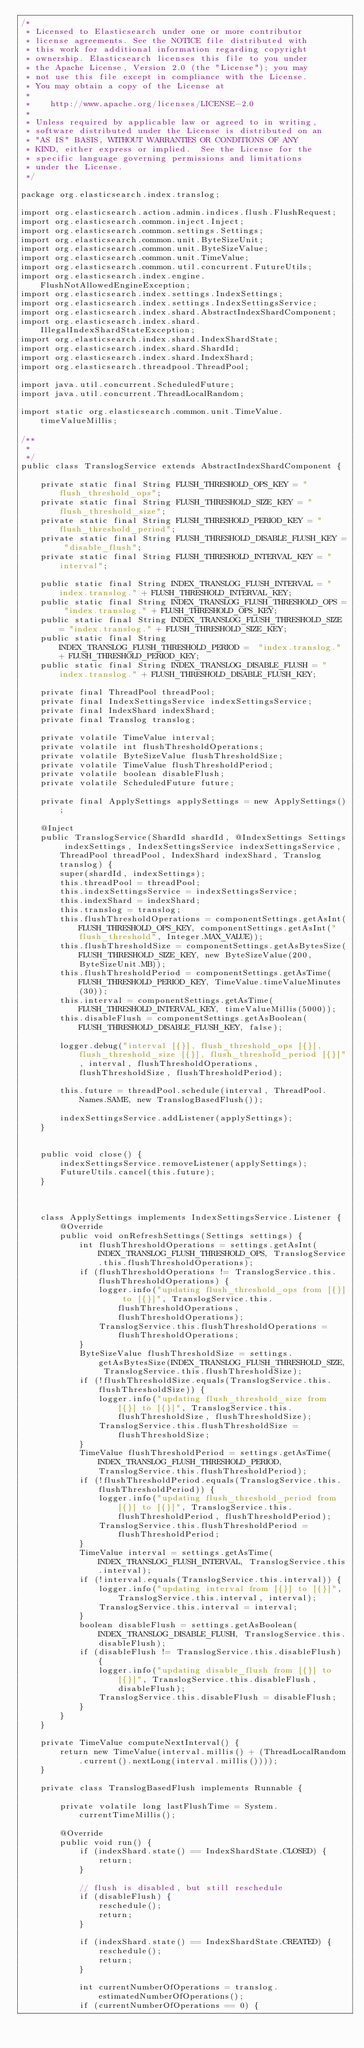Convert code to text. <code><loc_0><loc_0><loc_500><loc_500><_Java_>/*
 * Licensed to Elasticsearch under one or more contributor
 * license agreements. See the NOTICE file distributed with
 * this work for additional information regarding copyright
 * ownership. Elasticsearch licenses this file to you under
 * the Apache License, Version 2.0 (the "License"); you may
 * not use this file except in compliance with the License.
 * You may obtain a copy of the License at
 *
 *    http://www.apache.org/licenses/LICENSE-2.0
 *
 * Unless required by applicable law or agreed to in writing,
 * software distributed under the License is distributed on an
 * "AS IS" BASIS, WITHOUT WARRANTIES OR CONDITIONS OF ANY
 * KIND, either express or implied.  See the License for the
 * specific language governing permissions and limitations
 * under the License.
 */

package org.elasticsearch.index.translog;

import org.elasticsearch.action.admin.indices.flush.FlushRequest;
import org.elasticsearch.common.inject.Inject;
import org.elasticsearch.common.settings.Settings;
import org.elasticsearch.common.unit.ByteSizeUnit;
import org.elasticsearch.common.unit.ByteSizeValue;
import org.elasticsearch.common.unit.TimeValue;
import org.elasticsearch.common.util.concurrent.FutureUtils;
import org.elasticsearch.index.engine.FlushNotAllowedEngineException;
import org.elasticsearch.index.settings.IndexSettings;
import org.elasticsearch.index.settings.IndexSettingsService;
import org.elasticsearch.index.shard.AbstractIndexShardComponent;
import org.elasticsearch.index.shard.IllegalIndexShardStateException;
import org.elasticsearch.index.shard.IndexShardState;
import org.elasticsearch.index.shard.ShardId;
import org.elasticsearch.index.shard.IndexShard;
import org.elasticsearch.threadpool.ThreadPool;

import java.util.concurrent.ScheduledFuture;
import java.util.concurrent.ThreadLocalRandom;

import static org.elasticsearch.common.unit.TimeValue.timeValueMillis;

/**
 *
 */
public class TranslogService extends AbstractIndexShardComponent {

    private static final String FLUSH_THRESHOLD_OPS_KEY = "flush_threshold_ops";
    private static final String FLUSH_THRESHOLD_SIZE_KEY = "flush_threshold_size";
    private static final String FLUSH_THRESHOLD_PERIOD_KEY = "flush_threshold_period";
    private static final String FLUSH_THRESHOLD_DISABLE_FLUSH_KEY = "disable_flush";
    private static final String FLUSH_THRESHOLD_INTERVAL_KEY = "interval";

    public static final String INDEX_TRANSLOG_FLUSH_INTERVAL = "index.translog." + FLUSH_THRESHOLD_INTERVAL_KEY;
    public static final String INDEX_TRANSLOG_FLUSH_THRESHOLD_OPS = "index.translog." + FLUSH_THRESHOLD_OPS_KEY;
    public static final String INDEX_TRANSLOG_FLUSH_THRESHOLD_SIZE = "index.translog." + FLUSH_THRESHOLD_SIZE_KEY;
    public static final String INDEX_TRANSLOG_FLUSH_THRESHOLD_PERIOD =  "index.translog." + FLUSH_THRESHOLD_PERIOD_KEY;
    public static final String INDEX_TRANSLOG_DISABLE_FLUSH = "index.translog." + FLUSH_THRESHOLD_DISABLE_FLUSH_KEY;

    private final ThreadPool threadPool;
    private final IndexSettingsService indexSettingsService;
    private final IndexShard indexShard;
    private final Translog translog;

    private volatile TimeValue interval;
    private volatile int flushThresholdOperations;
    private volatile ByteSizeValue flushThresholdSize;
    private volatile TimeValue flushThresholdPeriod;
    private volatile boolean disableFlush;
    private volatile ScheduledFuture future;

    private final ApplySettings applySettings = new ApplySettings();

    @Inject
    public TranslogService(ShardId shardId, @IndexSettings Settings indexSettings, IndexSettingsService indexSettingsService, ThreadPool threadPool, IndexShard indexShard, Translog translog) {
        super(shardId, indexSettings);
        this.threadPool = threadPool;
        this.indexSettingsService = indexSettingsService;
        this.indexShard = indexShard;
        this.translog = translog;
        this.flushThresholdOperations = componentSettings.getAsInt(FLUSH_THRESHOLD_OPS_KEY, componentSettings.getAsInt("flush_threshold", Integer.MAX_VALUE));
        this.flushThresholdSize = componentSettings.getAsBytesSize(FLUSH_THRESHOLD_SIZE_KEY, new ByteSizeValue(200, ByteSizeUnit.MB));
        this.flushThresholdPeriod = componentSettings.getAsTime(FLUSH_THRESHOLD_PERIOD_KEY, TimeValue.timeValueMinutes(30));
        this.interval = componentSettings.getAsTime(FLUSH_THRESHOLD_INTERVAL_KEY, timeValueMillis(5000));
        this.disableFlush = componentSettings.getAsBoolean(FLUSH_THRESHOLD_DISABLE_FLUSH_KEY, false);

        logger.debug("interval [{}], flush_threshold_ops [{}], flush_threshold_size [{}], flush_threshold_period [{}]", interval, flushThresholdOperations, flushThresholdSize, flushThresholdPeriod);

        this.future = threadPool.schedule(interval, ThreadPool.Names.SAME, new TranslogBasedFlush());

        indexSettingsService.addListener(applySettings);
    }


    public void close() {
        indexSettingsService.removeListener(applySettings);
        FutureUtils.cancel(this.future);
    }



    class ApplySettings implements IndexSettingsService.Listener {
        @Override
        public void onRefreshSettings(Settings settings) {
            int flushThresholdOperations = settings.getAsInt(INDEX_TRANSLOG_FLUSH_THRESHOLD_OPS, TranslogService.this.flushThresholdOperations);
            if (flushThresholdOperations != TranslogService.this.flushThresholdOperations) {
                logger.info("updating flush_threshold_ops from [{}] to [{}]", TranslogService.this.flushThresholdOperations, flushThresholdOperations);
                TranslogService.this.flushThresholdOperations = flushThresholdOperations;
            }
            ByteSizeValue flushThresholdSize = settings.getAsBytesSize(INDEX_TRANSLOG_FLUSH_THRESHOLD_SIZE, TranslogService.this.flushThresholdSize);
            if (!flushThresholdSize.equals(TranslogService.this.flushThresholdSize)) {
                logger.info("updating flush_threshold_size from [{}] to [{}]", TranslogService.this.flushThresholdSize, flushThresholdSize);
                TranslogService.this.flushThresholdSize = flushThresholdSize;
            }
            TimeValue flushThresholdPeriod = settings.getAsTime(INDEX_TRANSLOG_FLUSH_THRESHOLD_PERIOD, TranslogService.this.flushThresholdPeriod);
            if (!flushThresholdPeriod.equals(TranslogService.this.flushThresholdPeriod)) {
                logger.info("updating flush_threshold_period from [{}] to [{}]", TranslogService.this.flushThresholdPeriod, flushThresholdPeriod);
                TranslogService.this.flushThresholdPeriod = flushThresholdPeriod;
            }
            TimeValue interval = settings.getAsTime(INDEX_TRANSLOG_FLUSH_INTERVAL, TranslogService.this.interval);
            if (!interval.equals(TranslogService.this.interval)) {
                logger.info("updating interval from [{}] to [{}]", TranslogService.this.interval, interval);
                TranslogService.this.interval = interval;
            }
            boolean disableFlush = settings.getAsBoolean(INDEX_TRANSLOG_DISABLE_FLUSH, TranslogService.this.disableFlush);
            if (disableFlush != TranslogService.this.disableFlush) {
                logger.info("updating disable_flush from [{}] to [{}]", TranslogService.this.disableFlush, disableFlush);
                TranslogService.this.disableFlush = disableFlush;
            }
        }
    }

    private TimeValue computeNextInterval() {
        return new TimeValue(interval.millis() + (ThreadLocalRandom.current().nextLong(interval.millis())));
    }

    private class TranslogBasedFlush implements Runnable {

        private volatile long lastFlushTime = System.currentTimeMillis();

        @Override
        public void run() {
            if (indexShard.state() == IndexShardState.CLOSED) {
                return;
            }

            // flush is disabled, but still reschedule
            if (disableFlush) {
                reschedule();
                return;
            }

            if (indexShard.state() == IndexShardState.CREATED) {
                reschedule();
                return;
            }

            int currentNumberOfOperations = translog.estimatedNumberOfOperations();
            if (currentNumberOfOperations == 0) {</code> 